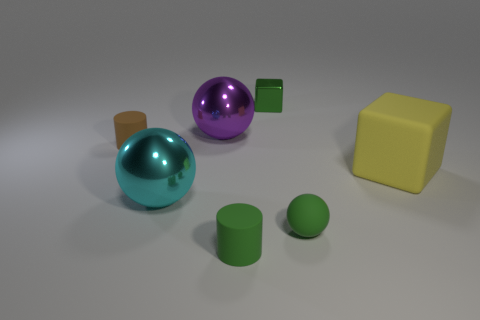Add 3 tiny gray metallic things. How many objects exist? 10 Subtract all green balls. How many balls are left? 2 Add 7 green rubber things. How many green rubber things exist? 9 Subtract all green balls. How many balls are left? 2 Subtract 1 green cubes. How many objects are left? 6 Subtract all cylinders. How many objects are left? 5 Subtract 1 spheres. How many spheres are left? 2 Subtract all yellow cubes. Subtract all brown balls. How many cubes are left? 1 Subtract all purple metallic cylinders. Subtract all matte blocks. How many objects are left? 6 Add 1 small green balls. How many small green balls are left? 2 